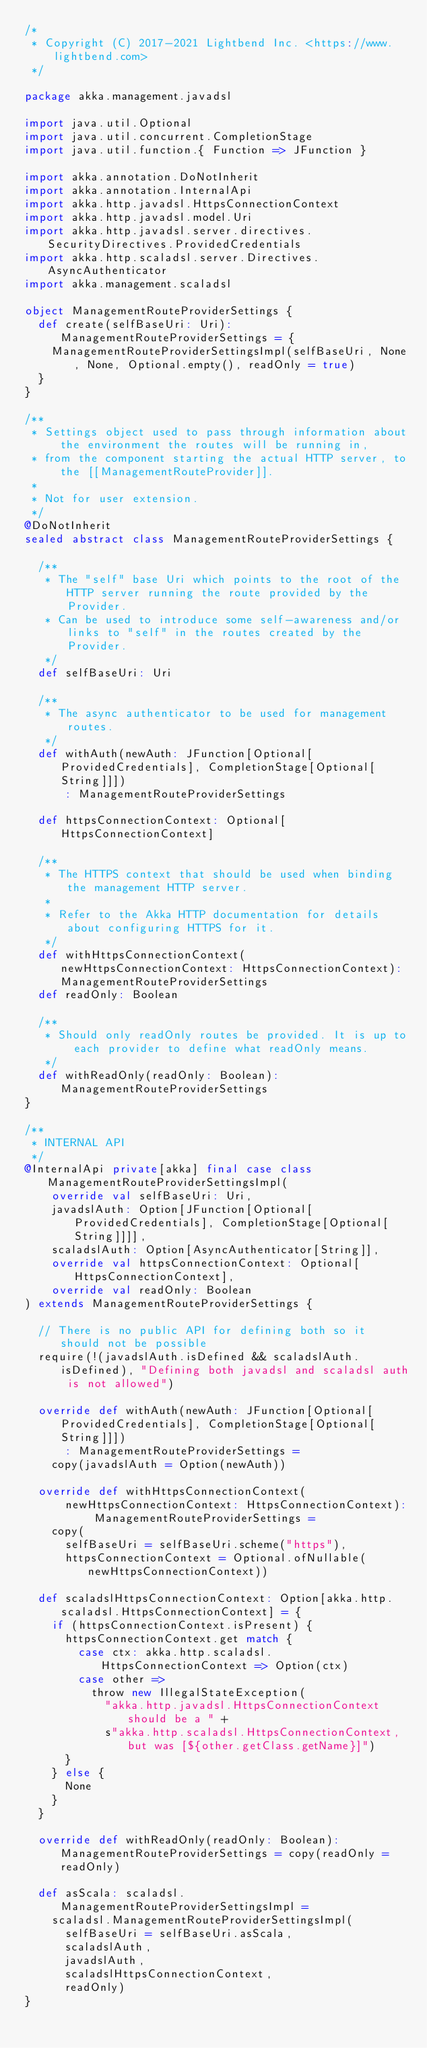Convert code to text. <code><loc_0><loc_0><loc_500><loc_500><_Scala_>/*
 * Copyright (C) 2017-2021 Lightbend Inc. <https://www.lightbend.com>
 */

package akka.management.javadsl

import java.util.Optional
import java.util.concurrent.CompletionStage
import java.util.function.{ Function => JFunction }

import akka.annotation.DoNotInherit
import akka.annotation.InternalApi
import akka.http.javadsl.HttpsConnectionContext
import akka.http.javadsl.model.Uri
import akka.http.javadsl.server.directives.SecurityDirectives.ProvidedCredentials
import akka.http.scaladsl.server.Directives.AsyncAuthenticator
import akka.management.scaladsl

object ManagementRouteProviderSettings {
  def create(selfBaseUri: Uri): ManagementRouteProviderSettings = {
    ManagementRouteProviderSettingsImpl(selfBaseUri, None, None, Optional.empty(), readOnly = true)
  }
}

/**
 * Settings object used to pass through information about the environment the routes will be running in,
 * from the component starting the actual HTTP server, to the [[ManagementRouteProvider]].
 *
 * Not for user extension.
 */
@DoNotInherit
sealed abstract class ManagementRouteProviderSettings {

  /**
   * The "self" base Uri which points to the root of the HTTP server running the route provided by the Provider.
   * Can be used to introduce some self-awareness and/or links to "self" in the routes created by the Provider.
   */
  def selfBaseUri: Uri

  /**
   * The async authenticator to be used for management routes.
   */
  def withAuth(newAuth: JFunction[Optional[ProvidedCredentials], CompletionStage[Optional[String]]])
      : ManagementRouteProviderSettings

  def httpsConnectionContext: Optional[HttpsConnectionContext]

  /**
   * The HTTPS context that should be used when binding the management HTTP server.
   *
   * Refer to the Akka HTTP documentation for details about configuring HTTPS for it.
   */
  def withHttpsConnectionContext(newHttpsConnectionContext: HttpsConnectionContext): ManagementRouteProviderSettings
  def readOnly: Boolean

  /**
   * Should only readOnly routes be provided. It is up to each provider to define what readOnly means.
   */
  def withReadOnly(readOnly: Boolean): ManagementRouteProviderSettings
}

/**
 * INTERNAL API
 */
@InternalApi private[akka] final case class ManagementRouteProviderSettingsImpl(
    override val selfBaseUri: Uri,
    javadslAuth: Option[JFunction[Optional[ProvidedCredentials], CompletionStage[Optional[String]]]],
    scaladslAuth: Option[AsyncAuthenticator[String]],
    override val httpsConnectionContext: Optional[HttpsConnectionContext],
    override val readOnly: Boolean
) extends ManagementRouteProviderSettings {

  // There is no public API for defining both so it should not be possible
  require(!(javadslAuth.isDefined && scaladslAuth.isDefined), "Defining both javadsl and scaladsl auth is not allowed")

  override def withAuth(newAuth: JFunction[Optional[ProvidedCredentials], CompletionStage[Optional[String]]])
      : ManagementRouteProviderSettings =
    copy(javadslAuth = Option(newAuth))

  override def withHttpsConnectionContext(
      newHttpsConnectionContext: HttpsConnectionContext): ManagementRouteProviderSettings =
    copy(
      selfBaseUri = selfBaseUri.scheme("https"),
      httpsConnectionContext = Optional.ofNullable(newHttpsConnectionContext))

  def scaladslHttpsConnectionContext: Option[akka.http.scaladsl.HttpsConnectionContext] = {
    if (httpsConnectionContext.isPresent) {
      httpsConnectionContext.get match {
        case ctx: akka.http.scaladsl.HttpsConnectionContext => Option(ctx)
        case other =>
          throw new IllegalStateException(
            "akka.http.javadsl.HttpsConnectionContext should be a " +
            s"akka.http.scaladsl.HttpsConnectionContext, but was [${other.getClass.getName}]")
      }
    } else {
      None
    }
  }

  override def withReadOnly(readOnly: Boolean): ManagementRouteProviderSettings = copy(readOnly = readOnly)

  def asScala: scaladsl.ManagementRouteProviderSettingsImpl =
    scaladsl.ManagementRouteProviderSettingsImpl(
      selfBaseUri = selfBaseUri.asScala,
      scaladslAuth,
      javadslAuth,
      scaladslHttpsConnectionContext,
      readOnly)
}
</code> 